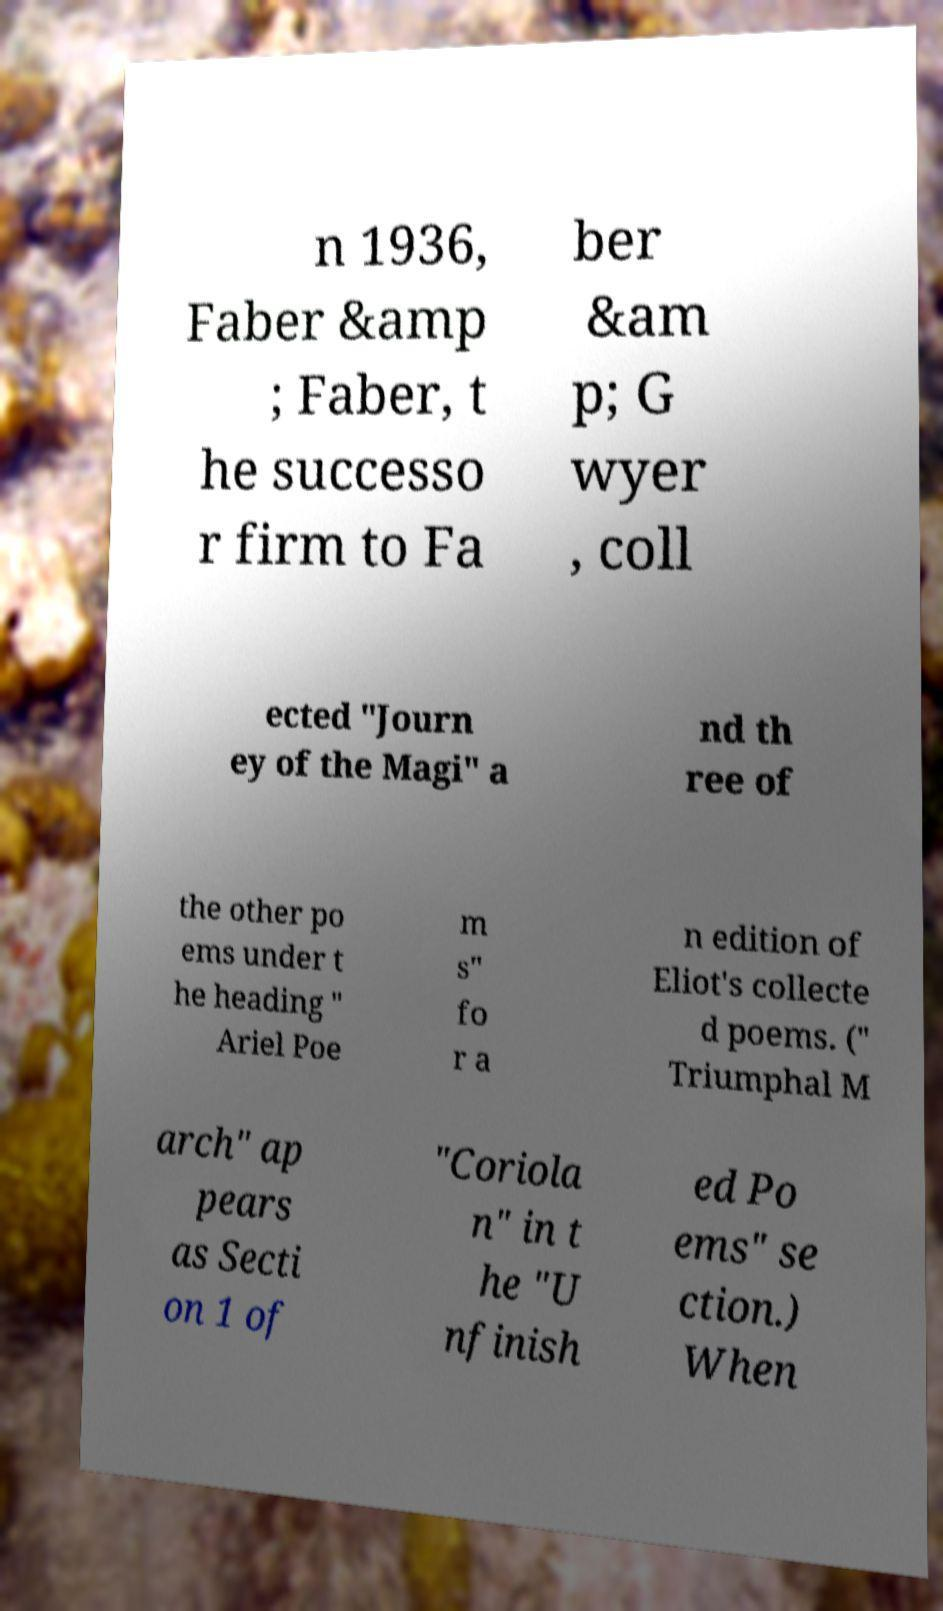Can you accurately transcribe the text from the provided image for me? n 1936, Faber &amp ; Faber, t he successo r firm to Fa ber &am p; G wyer , coll ected "Journ ey of the Magi" a nd th ree of the other po ems under t he heading " Ariel Poe m s" fo r a n edition of Eliot's collecte d poems. (" Triumphal M arch" ap pears as Secti on 1 of "Coriola n" in t he "U nfinish ed Po ems" se ction.) When 